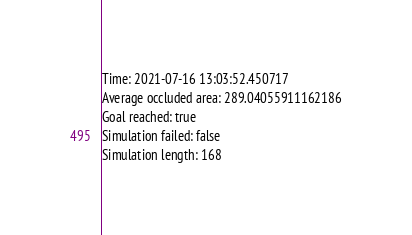Convert code to text. <code><loc_0><loc_0><loc_500><loc_500><_YAML_>Time: 2021-07-16 13:03:52.450717
Average occluded area: 289.04055911162186
Goal reached: true
Simulation failed: false
Simulation length: 168
</code> 